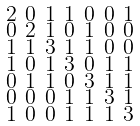<formula> <loc_0><loc_0><loc_500><loc_500>\begin{smallmatrix} 2 & 0 & 1 & 1 & 0 & 0 & 1 \\ 0 & 2 & 1 & 0 & 1 & 0 & 0 \\ 1 & 1 & 3 & 1 & 1 & 0 & 0 \\ 1 & 0 & 1 & 3 & 0 & 1 & 1 \\ 0 & 1 & 1 & 0 & 3 & 1 & 1 \\ 0 & 0 & 0 & 1 & 1 & 3 & 1 \\ 1 & 0 & 0 & 1 & 1 & 1 & 3 \end{smallmatrix}</formula> 